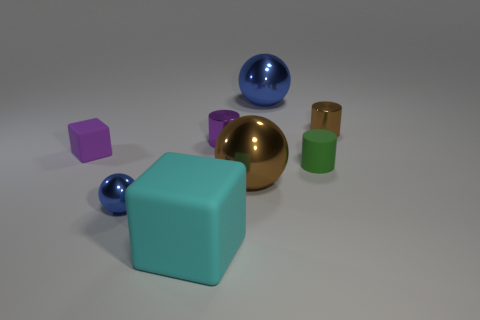Does the big metallic object behind the purple matte thing have the same shape as the brown object on the left side of the small brown metallic cylinder?
Provide a short and direct response. Yes. Are there more matte cylinders that are on the right side of the big brown ball than large gray rubber blocks?
Your answer should be compact. Yes. What number of things are either purple matte things or gray matte cylinders?
Your response must be concise. 1. The large block has what color?
Your answer should be very brief. Cyan. How many other things are the same color as the large block?
Make the answer very short. 0. There is a small blue shiny ball; are there any matte objects behind it?
Your answer should be very brief. Yes. There is a tiny matte object that is on the right side of the blue metallic object to the right of the metallic thing on the left side of the large rubber object; what color is it?
Your answer should be compact. Green. How many small objects are both to the right of the small purple block and behind the small green thing?
Keep it short and to the point. 2. How many cubes are green objects or large brown metallic things?
Offer a terse response. 0. Are any big metallic blocks visible?
Ensure brevity in your answer.  No. 